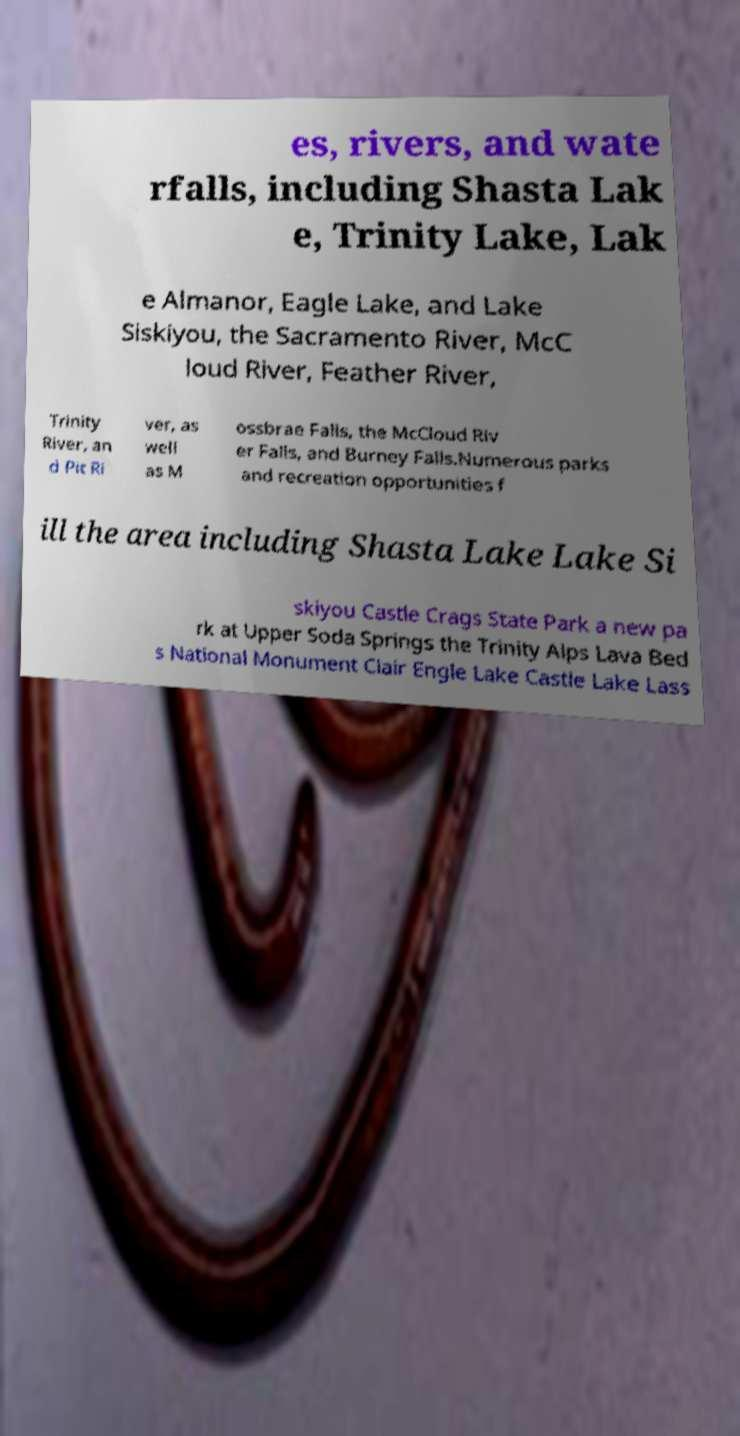Could you assist in decoding the text presented in this image and type it out clearly? es, rivers, and wate rfalls, including Shasta Lak e, Trinity Lake, Lak e Almanor, Eagle Lake, and Lake Siskiyou, the Sacramento River, McC loud River, Feather River, Trinity River, an d Pit Ri ver, as well as M ossbrae Falls, the McCloud Riv er Falls, and Burney Falls.Numerous parks and recreation opportunities f ill the area including Shasta Lake Lake Si skiyou Castle Crags State Park a new pa rk at Upper Soda Springs the Trinity Alps Lava Bed s National Monument Clair Engle Lake Castle Lake Lass 